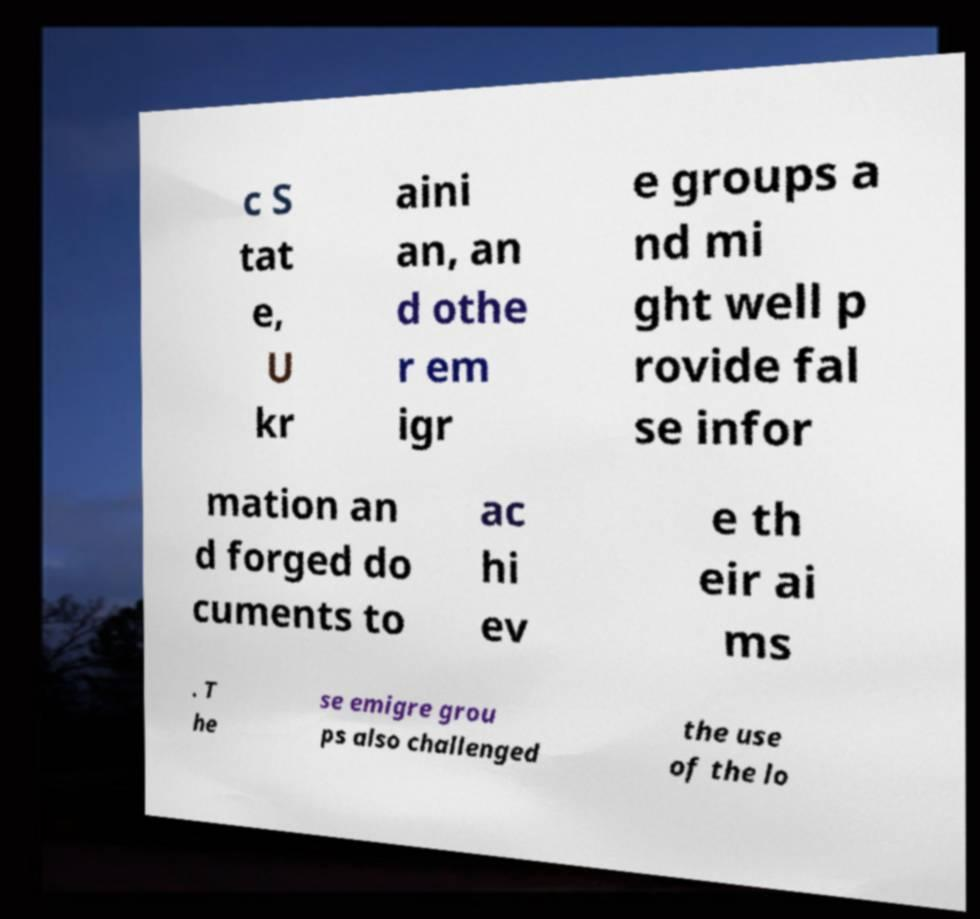Please identify and transcribe the text found in this image. c S tat e, U kr aini an, an d othe r em igr e groups a nd mi ght well p rovide fal se infor mation an d forged do cuments to ac hi ev e th eir ai ms . T he se emigre grou ps also challenged the use of the lo 